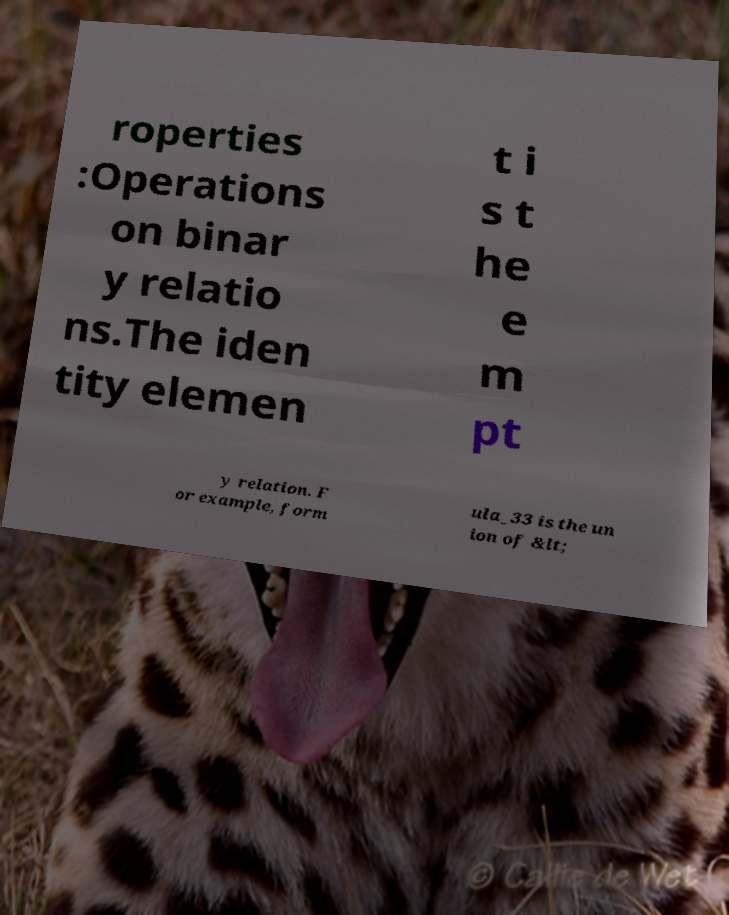Please read and relay the text visible in this image. What does it say? roperties :Operations on binar y relatio ns.The iden tity elemen t i s t he e m pt y relation. F or example, form ula_33 is the un ion of &lt; 